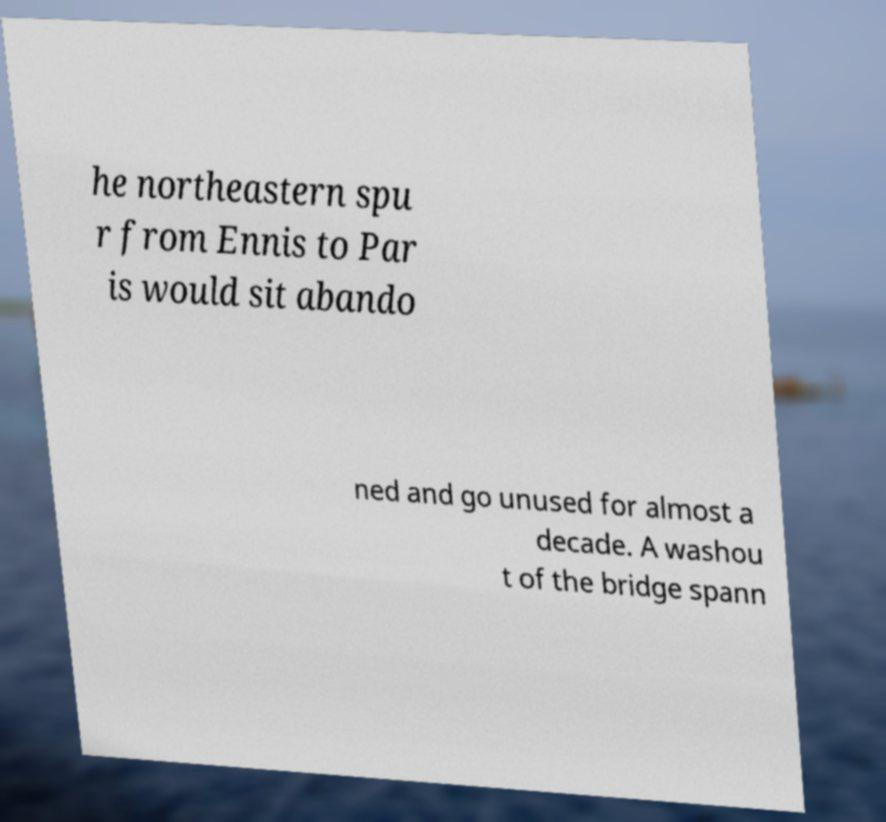There's text embedded in this image that I need extracted. Can you transcribe it verbatim? he northeastern spu r from Ennis to Par is would sit abando ned and go unused for almost a decade. A washou t of the bridge spann 